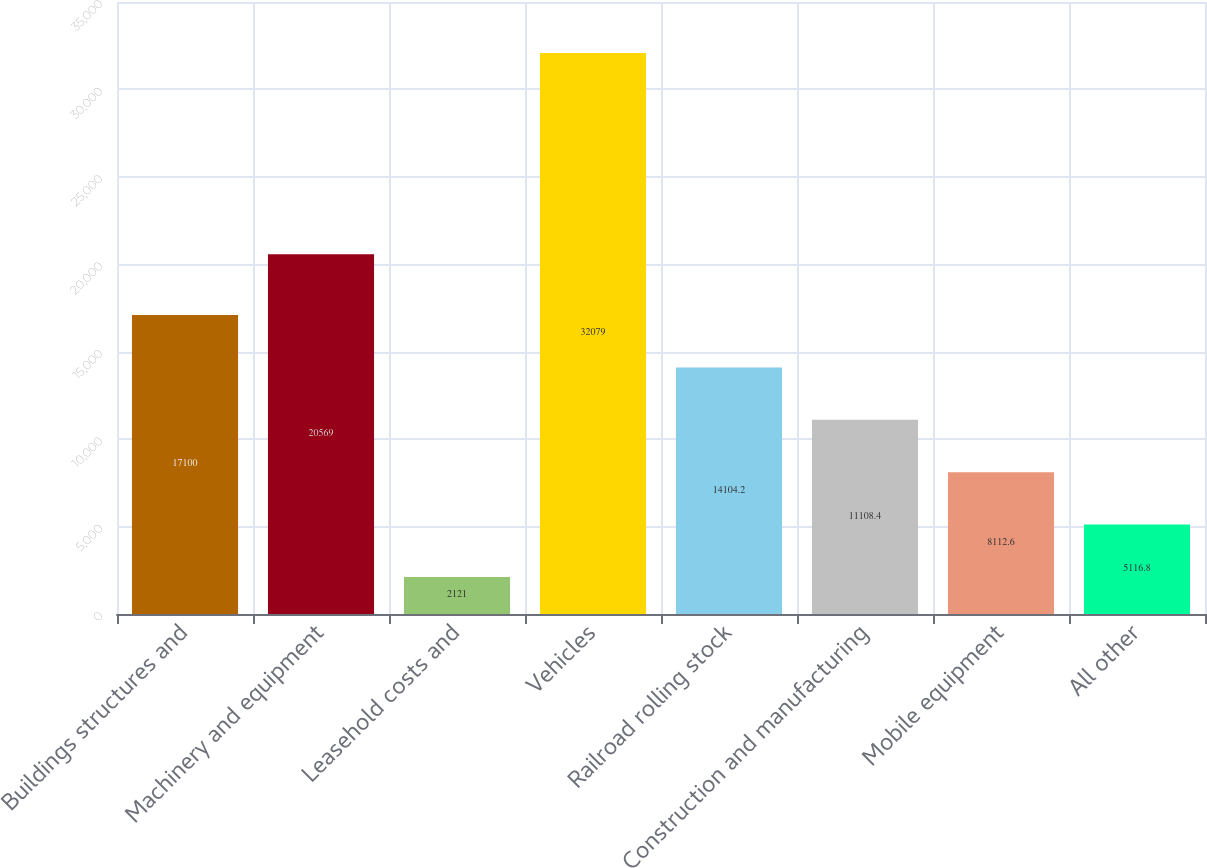Convert chart. <chart><loc_0><loc_0><loc_500><loc_500><bar_chart><fcel>Buildings structures and<fcel>Machinery and equipment<fcel>Leasehold costs and<fcel>Vehicles<fcel>Railroad rolling stock<fcel>Construction and manufacturing<fcel>Mobile equipment<fcel>All other<nl><fcel>17100<fcel>20569<fcel>2121<fcel>32079<fcel>14104.2<fcel>11108.4<fcel>8112.6<fcel>5116.8<nl></chart> 